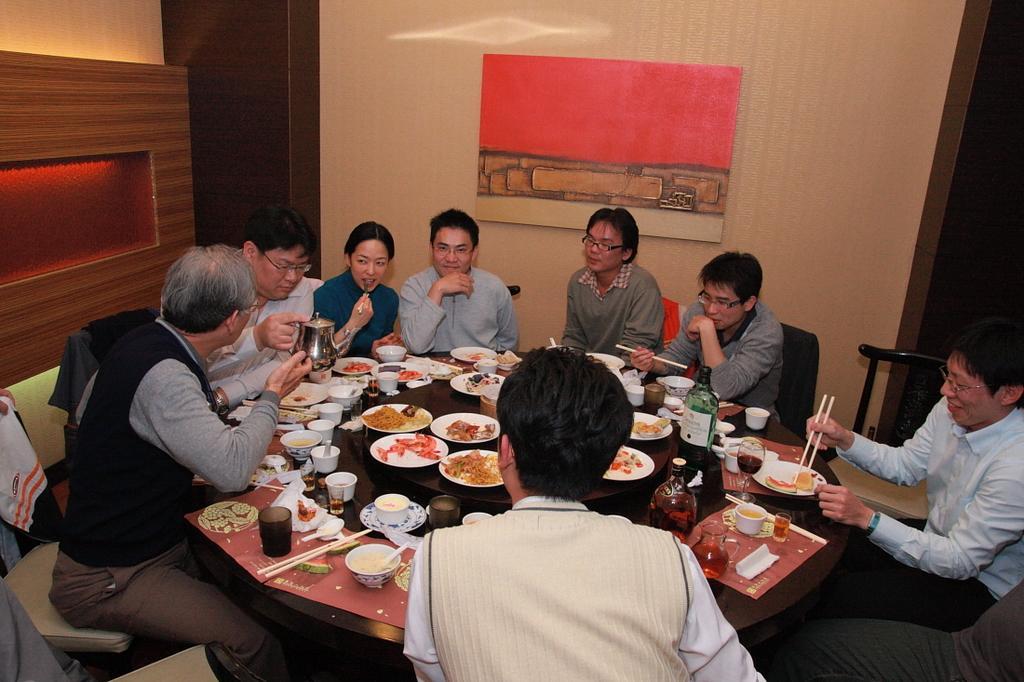In one or two sentences, can you explain what this image depicts? In this image i can see a group of persons sitting on a chair there are few plates, food , glasses on a table at the back ground i can see a wooden wall. 